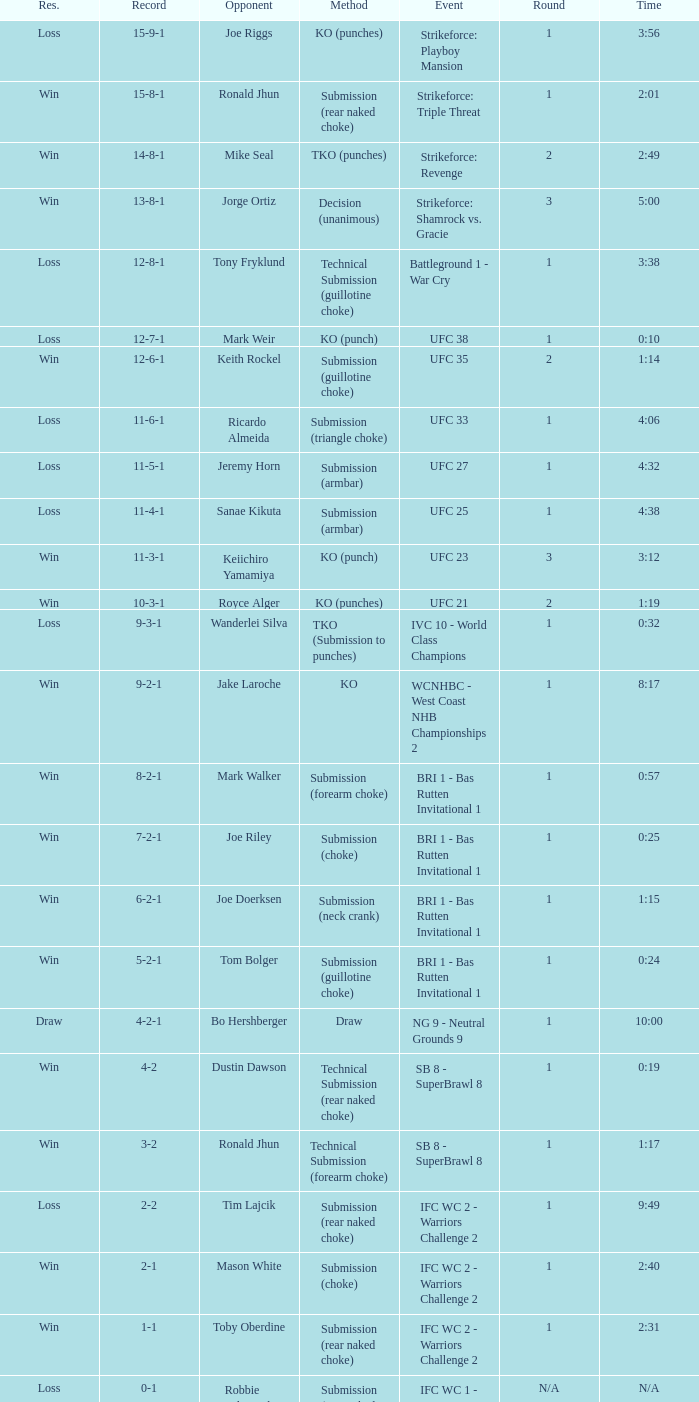What was the score when the technique of resolution was knockout? 9-2-1. 